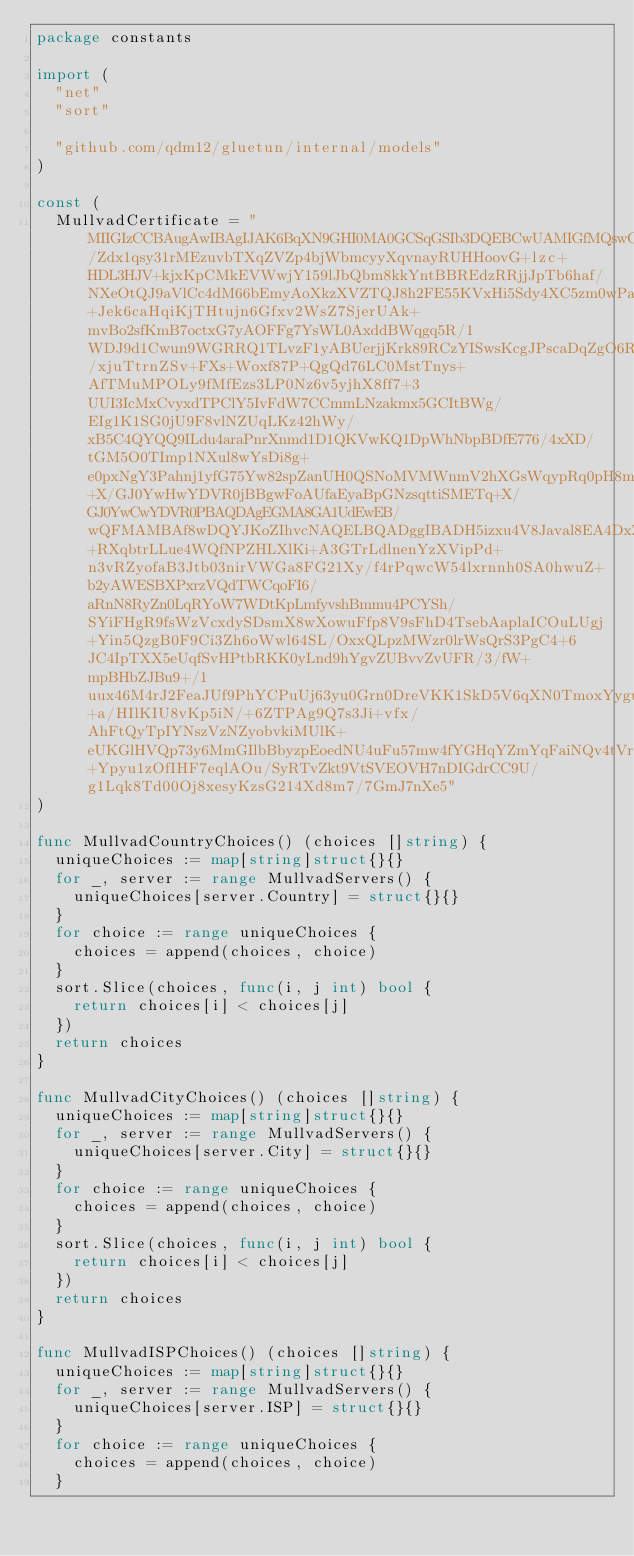Convert code to text. <code><loc_0><loc_0><loc_500><loc_500><_Go_>package constants

import (
	"net"
	"sort"

	"github.com/qdm12/gluetun/internal/models"
)

const (
	MullvadCertificate = "MIIGIzCCBAugAwIBAgIJAK6BqXN9GHI0MA0GCSqGSIb3DQEBCwUAMIGfMQswCQYDVQQGEwJTRTERMA8GA1UECAwIR290YWxhbmQxEzARBgNVBAcMCkdvdGhlbmJ1cmcxFDASBgNVBAoMC0FtYWdpY29tIEFCMRAwDgYDVQQLDAdNdWxsdmFkMRswGQYDVQQDDBJNdWxsdmFkIFJvb3QgQ0EgdjIxIzAhBgkqhkiG9w0BCQEWFHNlY3VyaXR5QG11bGx2YWQubmV0MB4XDTE4MTEwMjExMTYxMVoXDTI4MTAzMDExMTYxMVowgZ8xCzAJBgNVBAYTAlNFMREwDwYDVQQIDAhHb3RhbGFuZDETMBEGA1UEBwwKR290aGVuYnVyZzEUMBIGA1UECgwLQW1hZ2ljb20gQUIxEDAOBgNVBAsMB011bGx2YWQxGzAZBgNVBAMMEk11bGx2YWQgUm9vdCBDQSB2MjEjMCEGCSqGSIb3DQEJARYUc2VjdXJpdHlAbXVsbHZhZC5uZXQwggIiMA0GCSqGSIb3DQEBAQUAA4ICDwAwggIKAoICAQCifDn75E/Zdx1qsy31rMEzuvbTXqZVZp4bjWbmcyyXqvnayRUHHoovG+lzc+HDL3HJV+kjxKpCMkEVWwjY159lJbQbm8kkYntBBREdzRRjjJpTb6haf/NXeOtQJ9aVlCc4dM66bEmyAoXkzXVZTQJ8h2FE55KVxHi5Sdy4XC5zm0wPa4DPDokNp1qm3A9Xicq3HsflLbMZRCAGuI+Jek6caHqiKjTHtujn6Gfxv2WsZ7SjerUAk+mvBo2sfKmB7octxG7yAOFFg7YsWL0AxddBWqgq5R/1WDJ9d1Cwun9WGRRQ1TLvzF1yABUerjjKrk89RCzYISwsKcgJPscaDqZgO6RIruY/xjuTtrnZSv+FXs+Woxf87P+QgQd76LC0MstTnys+AfTMuMPOLy9fMfEzs3LP0Nz6v5yjhX8ff7+3UUI3IcMxCvyxdTPClY5IvFdW7CCmmLNzakmx5GCItBWg/EIg1K1SG0jU9F8vlNZUqLKz42hWy/xB5C4QYQQ9ILdu4araPnrXnmd1D1QKVwKQ1DpWhNbpBDfE776/4xXD/tGM5O0TImp1NXul8wYsDi8g+e0pxNgY3Pahnj1yfG75Yw82spZanUH0QSNoMVMWnmV2hXGsWqypRq0pH8mPeLzeKa82gzsAZsouRD1k8wFlYA4z9HQFxqfcntTqXuwQcQIDAQABo2AwXjAdBgNVHQ4EFgQUfaEyaBpGNzsqttiSMETq+X/GJ0YwHwYDVR0jBBgwFoAUfaEyaBpGNzsqttiSMETq+X/GJ0YwCwYDVR0PBAQDAgEGMA8GA1UdEwEB/wQFMAMBAf8wDQYJKoZIhvcNAQELBQADggIBADH5izxu4V8Javal8EA4DxZxIHUsWCg5cuopB28PsyJYpyKipsBoI8+RXqbtrLLue4WQfNPZHLXlKi+A3GTrLdlnenYzXVipPd+n3vRZyofaB3Jtb03nirVWGa8FG21Xy/f4rPqwcW54lxrnnh0SA0hwuZ+b2yAWESBXPxrzVQdTWCqoFI6/aRnN8RyZn0LqRYoW7WDtKpLmfyvshBmmu4PCYSh/SYiFHgR9fsWzVcxdySDsmX8wXowuFfp8V9sFhD4TsebAaplaICOuLUgj+Yin5QzgB0F9Ci3Zh6oWwl64SL/OxxQLpzMWzr0lrWsQrS3PgC4+6JC4IpTXX5eUqfSvHPtbRKK0yLnd9hYgvZUBvvZvUFR/3/fW+mpBHbZJBu9+/1uux46M4rJ2FeaJUf9PhYCPuUj63yu0Grn0DreVKK1SkD5V6qXN0TmoxYyguhfsIPCpI1VsdaSWuNjJ+a/HIlKIU8vKp5iN/+6ZTPAg9Q7s3Ji+vfx/AhFtQyTpIYNszVzNZyobvkiMUlK+eUKGlHVQp73y6MmGIlbBbyzpEoedNU4uFu57mw4fYGHqYZmYqFaiNQv4tVrGkg6p+Ypyu1zOfIHF7eqlAOu/SyRTvZkt9VtSVEOVH7nDIGdrCC9U/g1Lqk8Td00Oj8xesyKzsG214Xd8m7/7GmJ7nXe5"
)

func MullvadCountryChoices() (choices []string) {
	uniqueChoices := map[string]struct{}{}
	for _, server := range MullvadServers() {
		uniqueChoices[server.Country] = struct{}{}
	}
	for choice := range uniqueChoices {
		choices = append(choices, choice)
	}
	sort.Slice(choices, func(i, j int) bool {
		return choices[i] < choices[j]
	})
	return choices
}

func MullvadCityChoices() (choices []string) {
	uniqueChoices := map[string]struct{}{}
	for _, server := range MullvadServers() {
		uniqueChoices[server.City] = struct{}{}
	}
	for choice := range uniqueChoices {
		choices = append(choices, choice)
	}
	sort.Slice(choices, func(i, j int) bool {
		return choices[i] < choices[j]
	})
	return choices
}

func MullvadISPChoices() (choices []string) {
	uniqueChoices := map[string]struct{}{}
	for _, server := range MullvadServers() {
		uniqueChoices[server.ISP] = struct{}{}
	}
	for choice := range uniqueChoices {
		choices = append(choices, choice)
	}</code> 